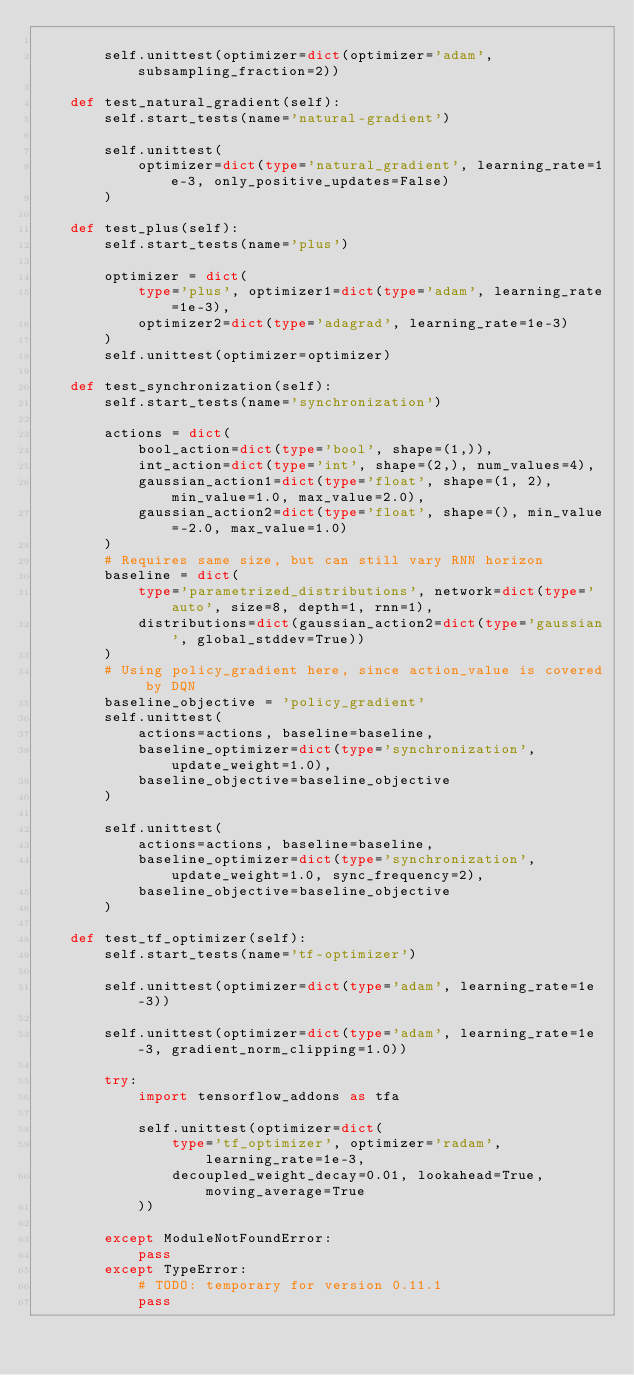<code> <loc_0><loc_0><loc_500><loc_500><_Python_>
        self.unittest(optimizer=dict(optimizer='adam', subsampling_fraction=2))

    def test_natural_gradient(self):
        self.start_tests(name='natural-gradient')

        self.unittest(
            optimizer=dict(type='natural_gradient', learning_rate=1e-3, only_positive_updates=False)
        )

    def test_plus(self):
        self.start_tests(name='plus')

        optimizer = dict(
            type='plus', optimizer1=dict(type='adam', learning_rate=1e-3),
            optimizer2=dict(type='adagrad', learning_rate=1e-3)
        )
        self.unittest(optimizer=optimizer)

    def test_synchronization(self):
        self.start_tests(name='synchronization')

        actions = dict(
            bool_action=dict(type='bool', shape=(1,)),
            int_action=dict(type='int', shape=(2,), num_values=4),
            gaussian_action1=dict(type='float', shape=(1, 2), min_value=1.0, max_value=2.0),
            gaussian_action2=dict(type='float', shape=(), min_value=-2.0, max_value=1.0)
        )
        # Requires same size, but can still vary RNN horizon
        baseline = dict(
            type='parametrized_distributions', network=dict(type='auto', size=8, depth=1, rnn=1),
            distributions=dict(gaussian_action2=dict(type='gaussian', global_stddev=True))
        )
        # Using policy_gradient here, since action_value is covered by DQN
        baseline_objective = 'policy_gradient'
        self.unittest(
            actions=actions, baseline=baseline,
            baseline_optimizer=dict(type='synchronization', update_weight=1.0),
            baseline_objective=baseline_objective
        )

        self.unittest(
            actions=actions, baseline=baseline,
            baseline_optimizer=dict(type='synchronization', update_weight=1.0, sync_frequency=2),
            baseline_objective=baseline_objective
        )

    def test_tf_optimizer(self):
        self.start_tests(name='tf-optimizer')

        self.unittest(optimizer=dict(type='adam', learning_rate=1e-3))

        self.unittest(optimizer=dict(type='adam', learning_rate=1e-3, gradient_norm_clipping=1.0))

        try:
            import tensorflow_addons as tfa

            self.unittest(optimizer=dict(
                type='tf_optimizer', optimizer='radam', learning_rate=1e-3,
                decoupled_weight_decay=0.01, lookahead=True, moving_average=True
            ))

        except ModuleNotFoundError:
            pass
        except TypeError:
            # TODO: temporary for version 0.11.1
            pass
</code> 